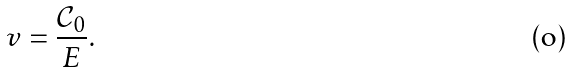<formula> <loc_0><loc_0><loc_500><loc_500>v = \frac { \mathcal { C } _ { 0 } } { E } .</formula> 